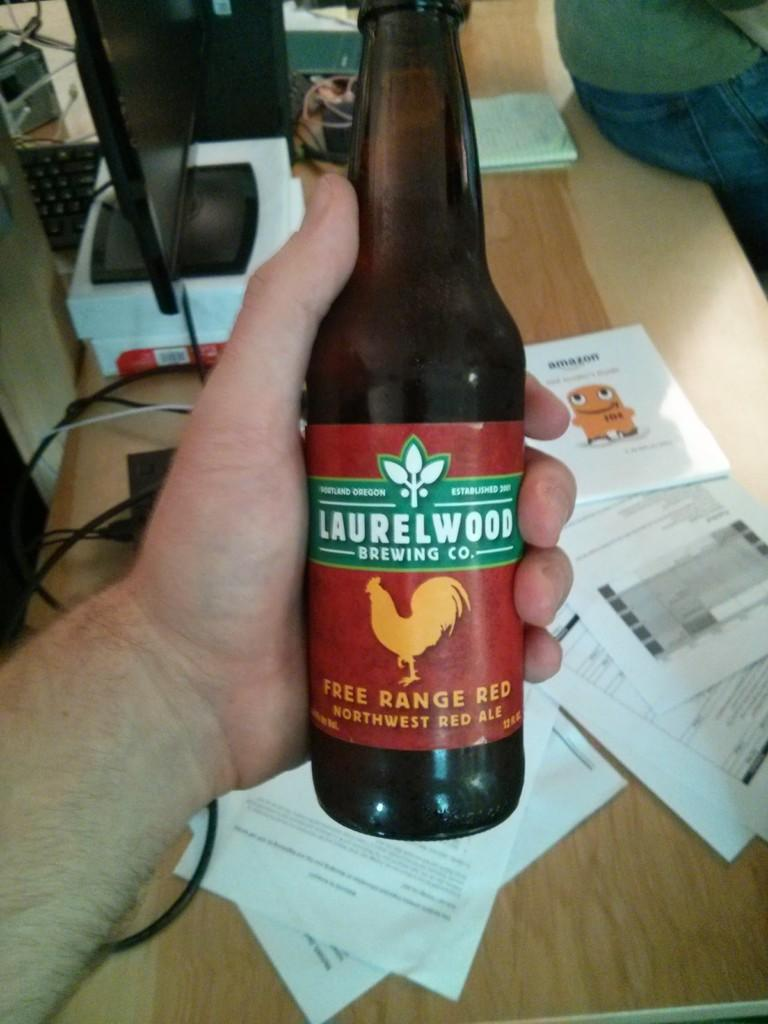<image>
Give a short and clear explanation of the subsequent image. A bottle of Laurelwood brewing co. red ale 